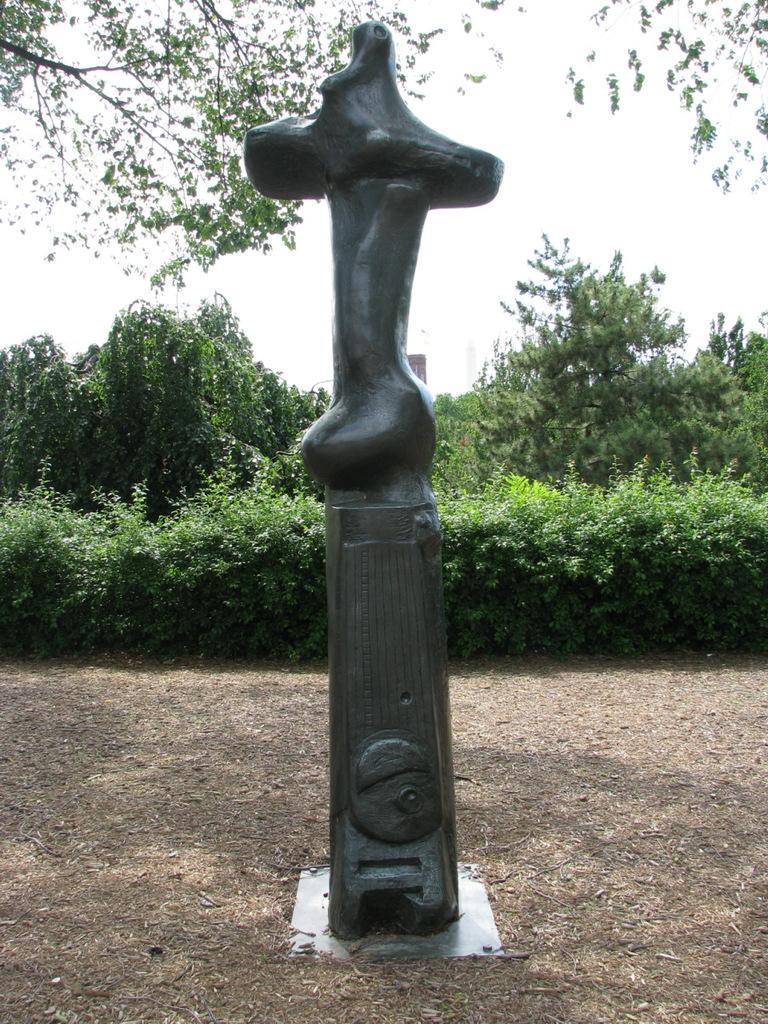Describe this image in one or two sentences. This is a picture of a sculpture or a statue and at the back ground there are plants, trees, building, sky. 